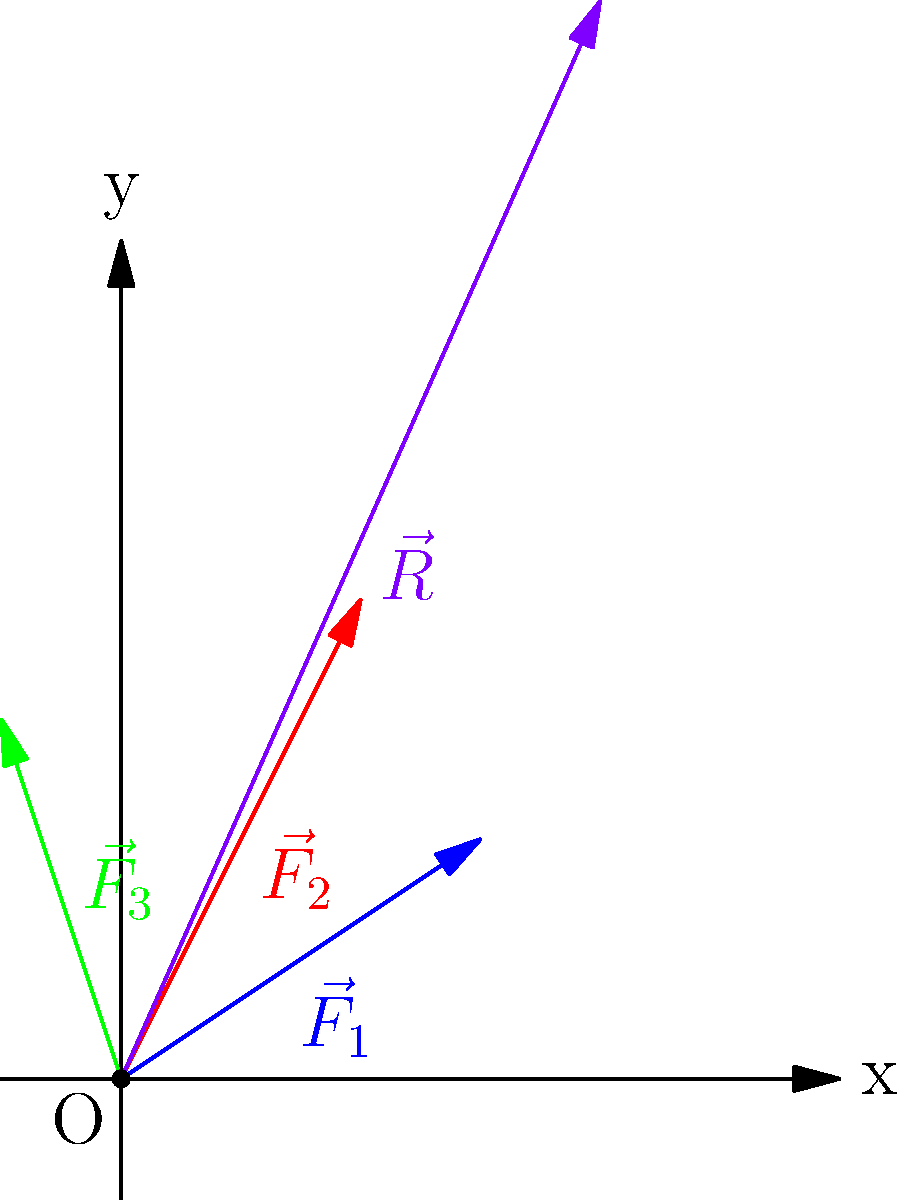In a wind resistance experiment for different fabrics, three force vectors represent the wind resistance on different samples: $\vec{F}_1 = 3\hat{i} + 2\hat{j}$, $\vec{F}_2 = 2\hat{i} + 4\hat{j}$, and $\vec{F}_3 = -\hat{i} + 3\hat{j}$. Calculate the magnitude of the resultant force vector $\vec{R}$ acting on the combined fabric samples. To find the magnitude of the resultant force vector, we need to follow these steps:

1) First, add the three force vectors to find the resultant vector $\vec{R}$:
   $\vec{R} = \vec{F}_1 + \vec{F}_2 + \vec{F}_3$
   
2) Substitute the given values:
   $\vec{R} = (3\hat{i} + 2\hat{j}) + (2\hat{i} + 4\hat{j}) + (-\hat{i} + 3\hat{j})$
   
3) Add the components:
   $\vec{R} = (3 + 2 - 1)\hat{i} + (2 + 4 + 3)\hat{j}$
   $\vec{R} = 4\hat{i} + 9\hat{j}$
   
4) The magnitude of a vector is given by the square root of the sum of the squares of its components:
   $|\vec{R}| = \sqrt{x^2 + y^2}$
   
5) Substitute the values:
   $|\vec{R}| = \sqrt{4^2 + 9^2}$
   
6) Calculate:
   $|\vec{R}| = \sqrt{16 + 81} = \sqrt{97}$

Therefore, the magnitude of the resultant force vector is $\sqrt{97}$ units.
Answer: $\sqrt{97}$ units 